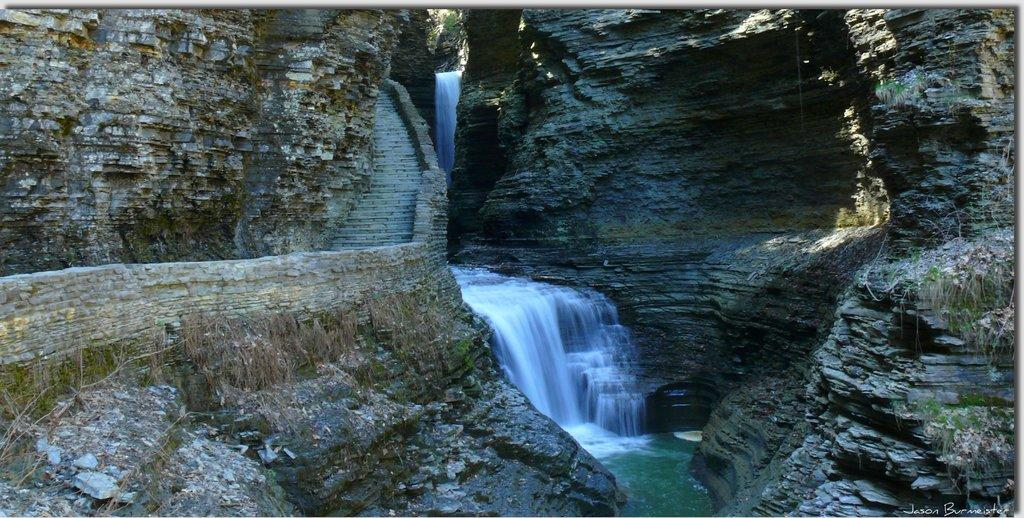What is happening in the middle of the image? Water is falling from rocks in the middle of the image. What type of geological formations are present on the left side of the image? There are rock mountains on the left side of the image. What type of geological formations are present on the right side of the image? There are rock mountains on the right side of the image. Can you tell me how many friends are visible in the image? There are no friends present in the image; it features water falling from rocks and rock mountains. What type of prose can be seen written on the rock mountains? There is no prose visible on the rock mountains in the image. 